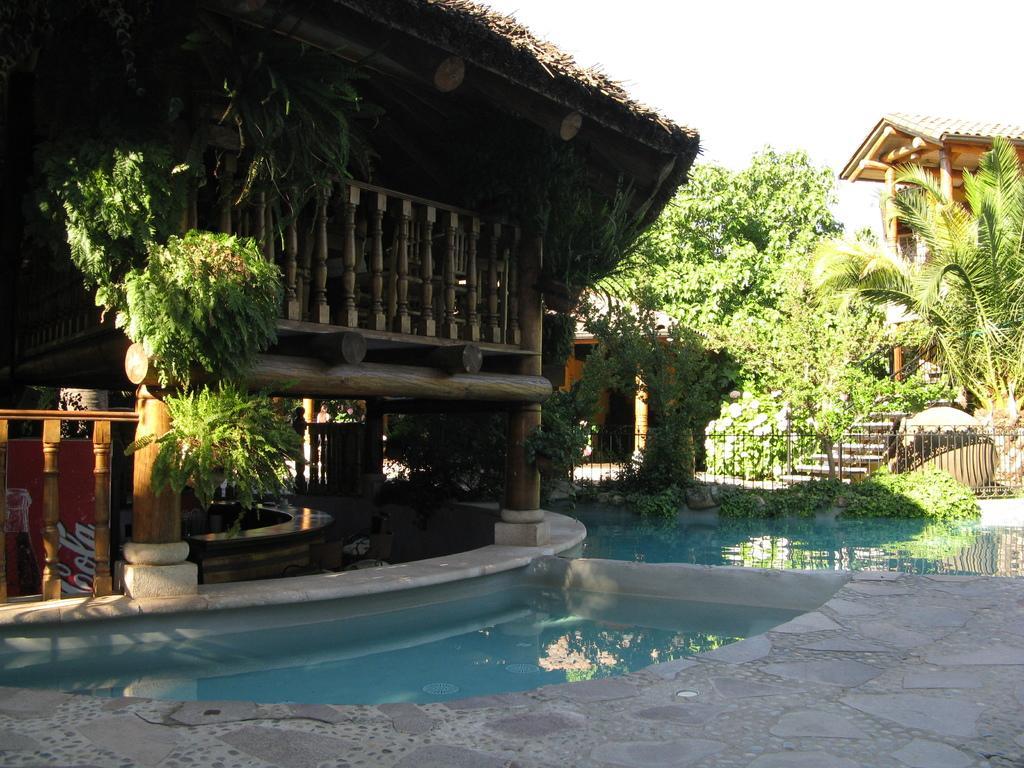Can you describe this image briefly? In this image we can see a house, pool, creepers, iron grill, floor and sky. 